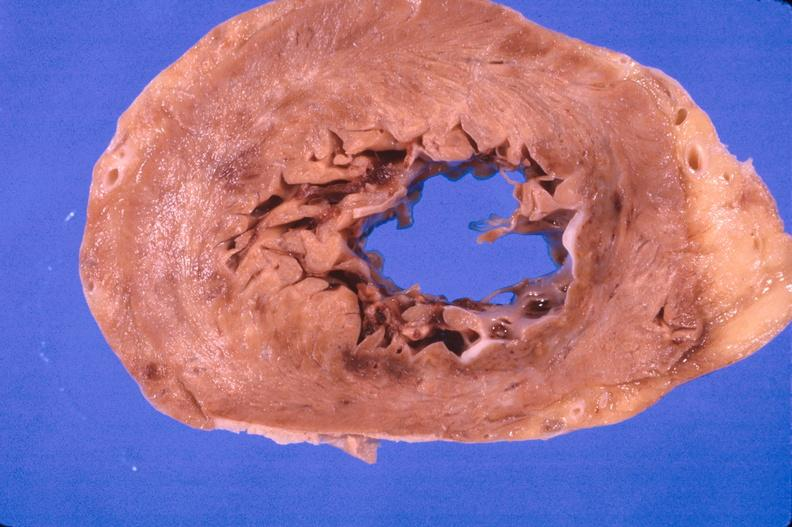s cardiovascular present?
Answer the question using a single word or phrase. Yes 